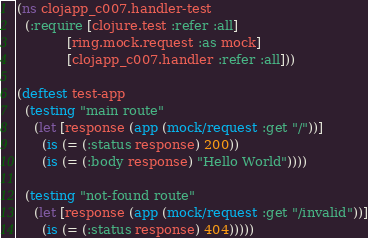<code> <loc_0><loc_0><loc_500><loc_500><_Clojure_>(ns clojapp_c007.handler-test
  (:require [clojure.test :refer :all]
            [ring.mock.request :as mock]
            [clojapp_c007.handler :refer :all]))

(deftest test-app
  (testing "main route"
    (let [response (app (mock/request :get "/"))]
      (is (= (:status response) 200))
      (is (= (:body response) "Hello World"))))

  (testing "not-found route"
    (let [response (app (mock/request :get "/invalid"))]
      (is (= (:status response) 404)))))
</code> 